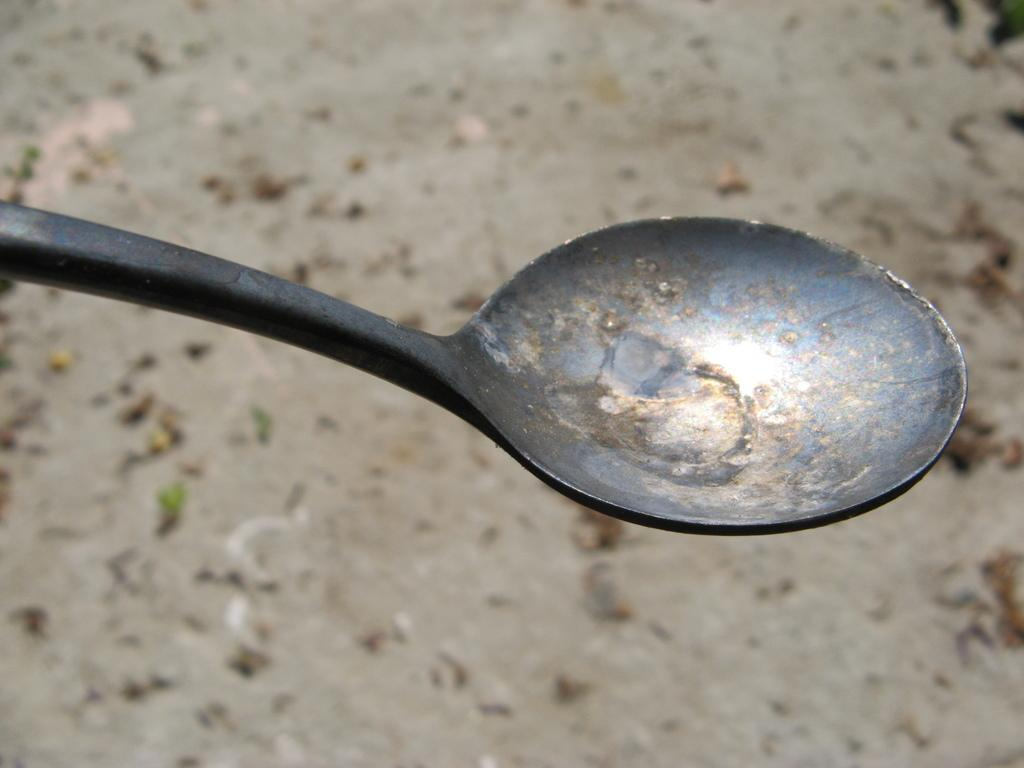What utensil can be seen in the image? There is a spoon in the image. What might the spoon be used for? The spoon might be used for eating or serving food. Can you describe the size or shape of the spoon? The facts provided do not specify the size or shape of the spoon. How many ants are carrying the spoon in the image? There are no ants present in the image, and therefore no ants are carrying the spoon. 